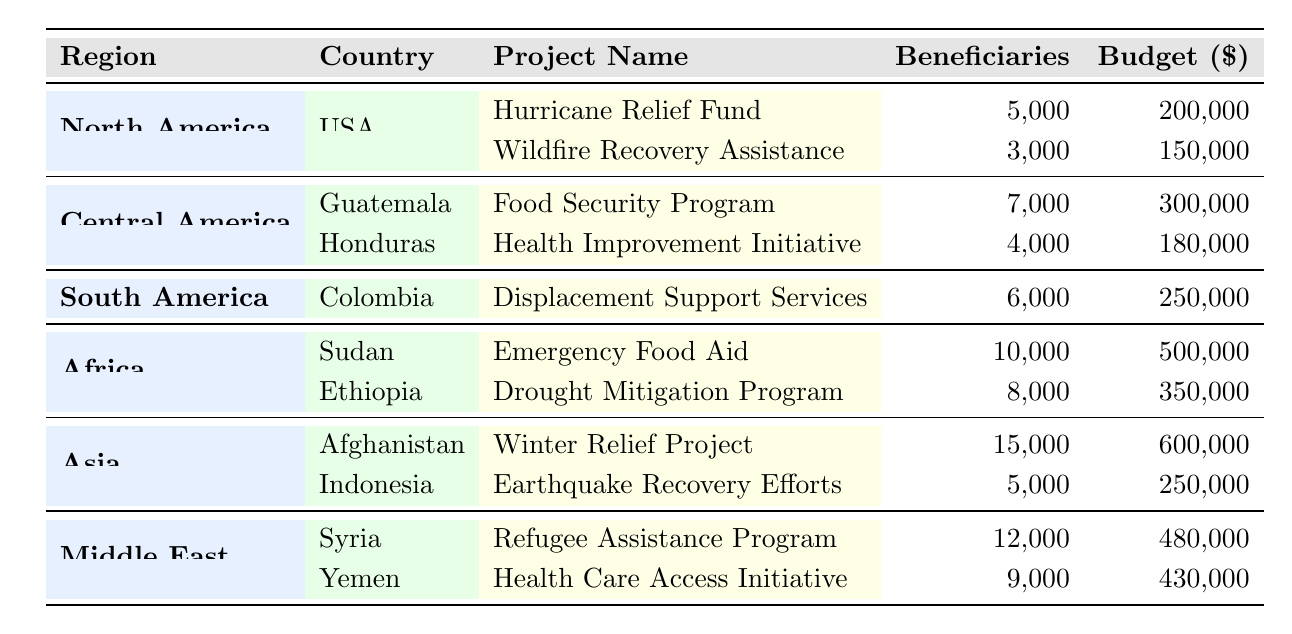What is the total number of beneficiaries for projects in Africa? In Africa, there are two projects: Emergency Food Aid with 10,000 beneficiaries and Drought Mitigation Program with 8,000 beneficiaries. Adding these gives 10,000 + 8,000 = 18,000 beneficiaries.
Answer: 18,000 Which project in North America has the highest budget? In North America, there are two projects: Hurricane Relief Fund with a budget of 200,000 and Wildfire Recovery Assistance with a budget of 150,000. The Hurricane Relief Fund has the highest budget.
Answer: Hurricane Relief Fund Is there a project in Central America that has more beneficiaries than the one in Honduras? In Central America, the Food Security Program in Guatemala has 7,000 beneficiaries, while the Health Improvement Initiative in Honduras has 4,000 beneficiaries. Since 7,000 is greater than 4,000, the statement is true.
Answer: Yes How much total budget is allocated for all projects in Asia? The budget for projects in Asia includes the Winter Relief Project in Afghanistan with 600,000 and Earthquake Recovery Efforts in Indonesia with 250,000. The total budget is 600,000 + 250,000 = 850,000.
Answer: 850,000 What are the names of the countries in the Middle East that received USAID projects? In the Middle East, two countries received projects: Syria and Yemen. The projects listed correspond to these two countries.
Answer: Syria, Yemen Which region has the fewest projects based on the table? After reviewing the projects listed for each region, South America has only one project (Displacement Support Services in Colombia), which is fewer than any other region that has multiple projects.
Answer: South America What is the average number of beneficiaries across all projects? The total beneficiaries from all projects are 5,000 + 3,000 + 7,000 + 4,000 + 6,000 + 10,000 + 8,000 + 15,000 + 5,000 + 12,000 + 9,000, totaling 70,000. There are 11 projects, so the average is 70,000 / 11 ≈ 6,364.
Answer: 6,364 Does any project in Asia have a budget of less than 300,000? Looking at the projects in Asia, the Winter Relief Project costs 600,000, while the Earthquake Recovery Efforts costs 250,000. Since 250,000 is less than 300,000, the statement is true.
Answer: Yes Which project has the highest number of beneficiaries and what is that number? The project with the highest number of beneficiaries is the Winter Relief Project in Afghanistan, with 15,000 beneficiaries, which is more than any other project listed in the table.
Answer: 15,000 